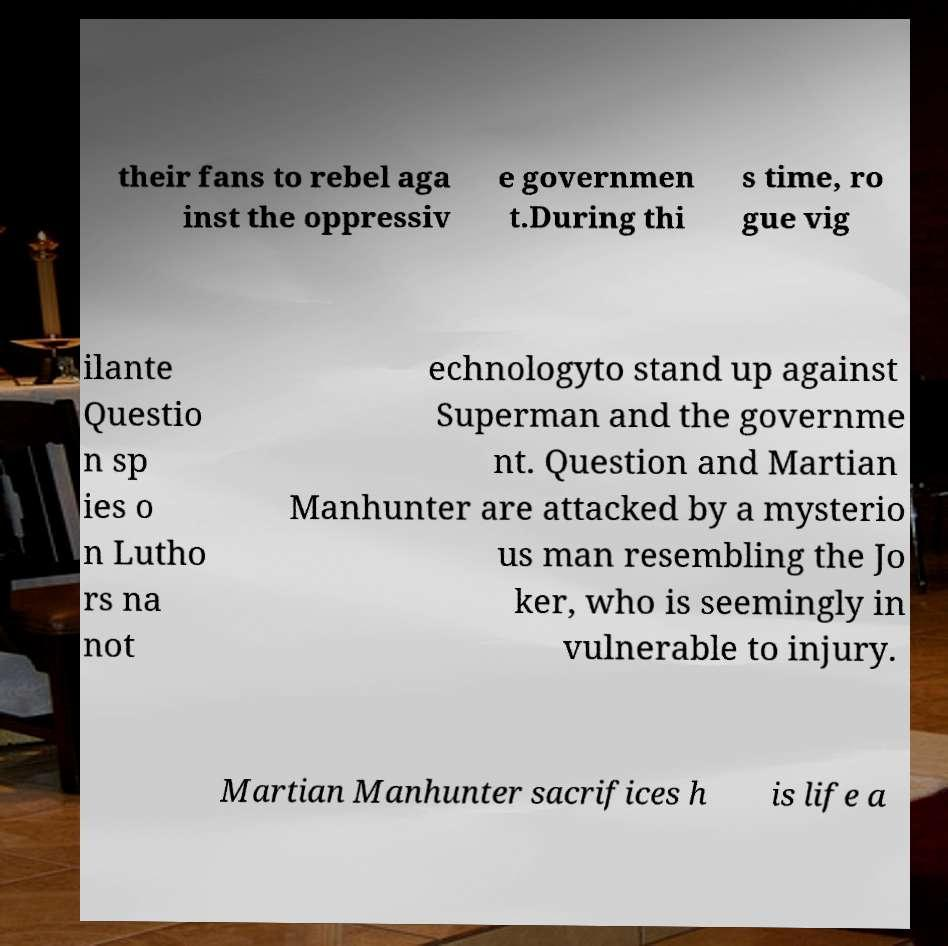Can you accurately transcribe the text from the provided image for me? their fans to rebel aga inst the oppressiv e governmen t.During thi s time, ro gue vig ilante Questio n sp ies o n Lutho rs na not echnologyto stand up against Superman and the governme nt. Question and Martian Manhunter are attacked by a mysterio us man resembling the Jo ker, who is seemingly in vulnerable to injury. Martian Manhunter sacrifices h is life a 